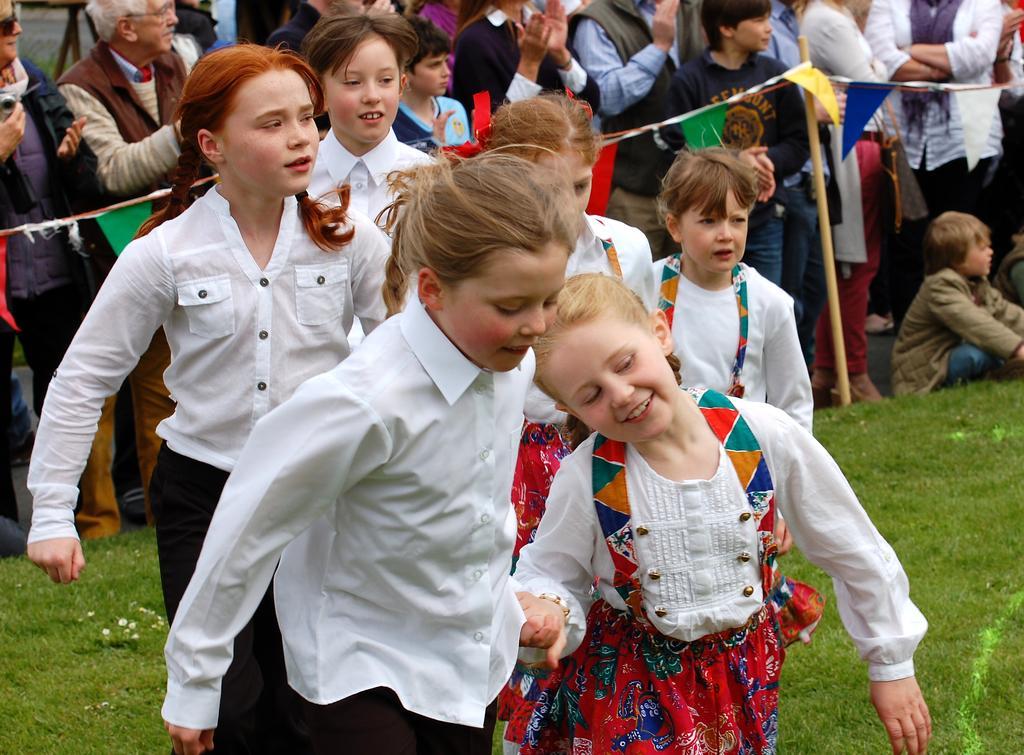How would you summarize this image in a sentence or two? In the image we can see there are kids standing on the ground and the ground is covered with grass. The kids are wearing costumes, there are spectators standing and watching them. There are wooden poles on the ground and there is rope tied to the wooden ropes. 